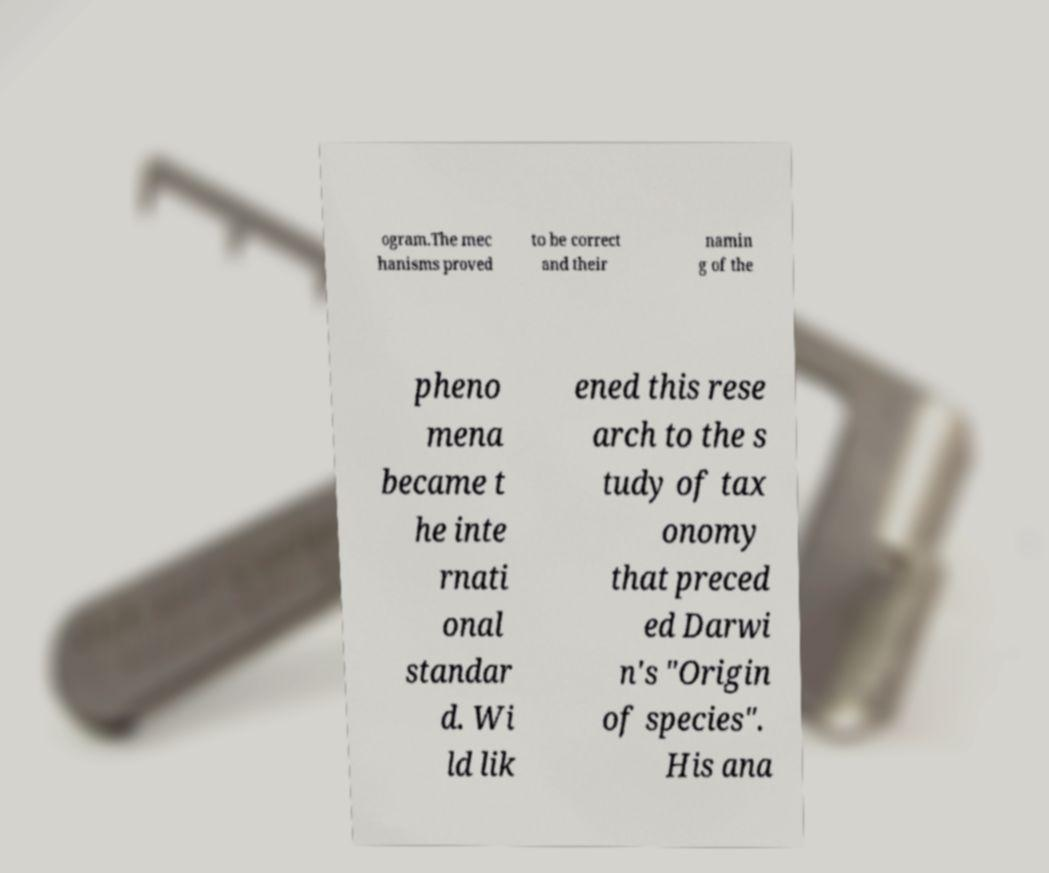I need the written content from this picture converted into text. Can you do that? ogram.The mec hanisms proved to be correct and their namin g of the pheno mena became t he inte rnati onal standar d. Wi ld lik ened this rese arch to the s tudy of tax onomy that preced ed Darwi n's "Origin of species". His ana 